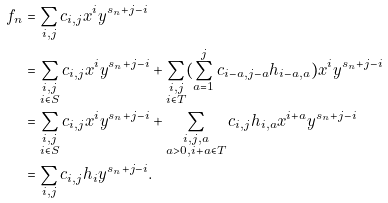<formula> <loc_0><loc_0><loc_500><loc_500>f _ { n } & = \sum _ { i , j } c _ { i , j } x ^ { i } y ^ { s _ { n } + j - i } \\ & = \sum _ { \substack { i , j \\ i \in S } } c _ { i , j } x ^ { i } y ^ { s _ { n } + j - i } + \sum _ { \substack { i , j \\ i \in T } } ( \sum _ { a = 1 } ^ { j } c _ { i - a , j - a } h _ { i - a , a } ) x ^ { i } y ^ { s _ { n } + j - i } \\ & = \sum _ { \substack { i , j \\ i \in S } } c _ { i , j } x ^ { i } y ^ { s _ { n } + j - i } + \sum _ { \substack { i , j , a \\ a > 0 , i + a \in T } } c _ { i , j } h _ { i , a } x ^ { i + a } y ^ { s _ { n } + j - i } \\ & = \sum _ { i , j } c _ { i , j } h _ { i } y ^ { s _ { n } + j - i } .</formula> 